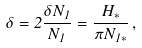<formula> <loc_0><loc_0><loc_500><loc_500>\delta = 2 \frac { \delta N _ { 1 } } { N _ { 1 } } = \frac { H _ { \ast } } { \pi N _ { 1 \ast } } \, ,</formula> 